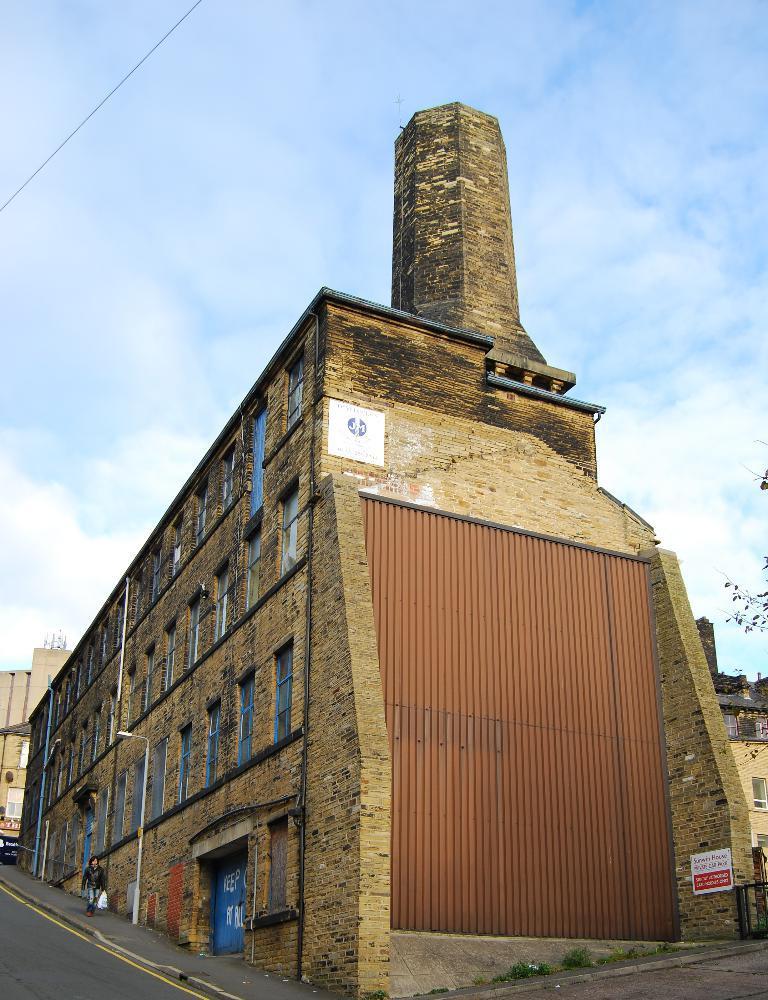Please provide a concise description of this image. In this picture we can observe a building which is in brown color. There are some windows. There is a road. We can observe a person walking on the footpath. In the background there is a sky with some clouds. 